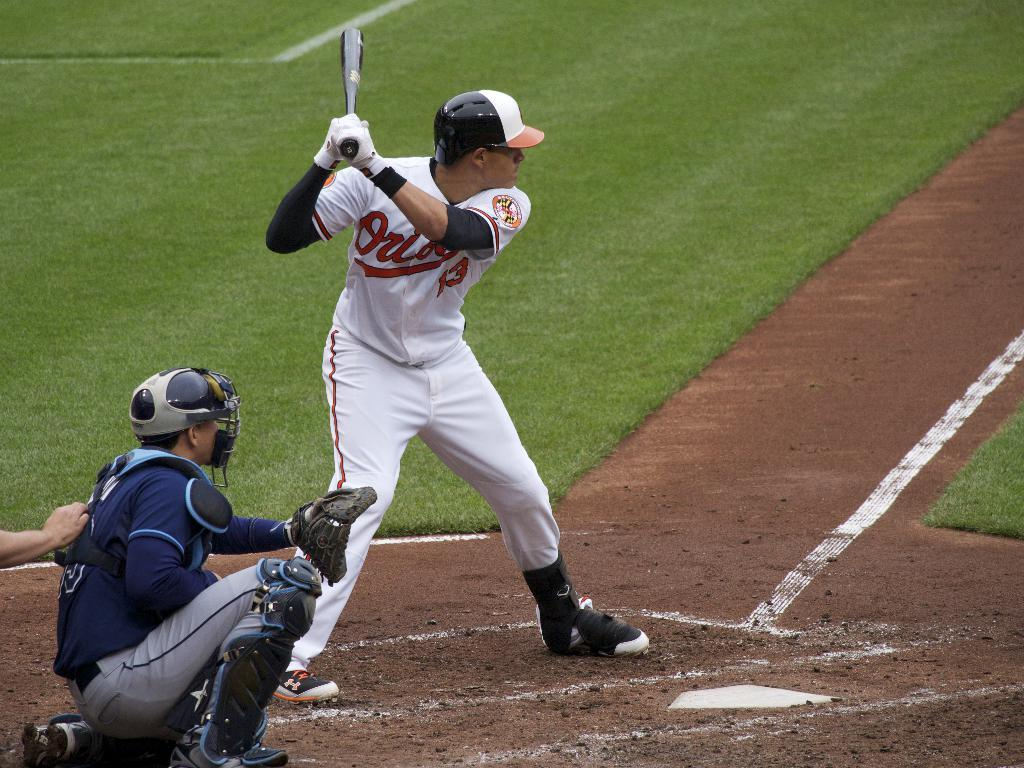<image>
Write a terse but informative summary of the picture. The player from the Orioles is batting while the catcher crouches behind him. 